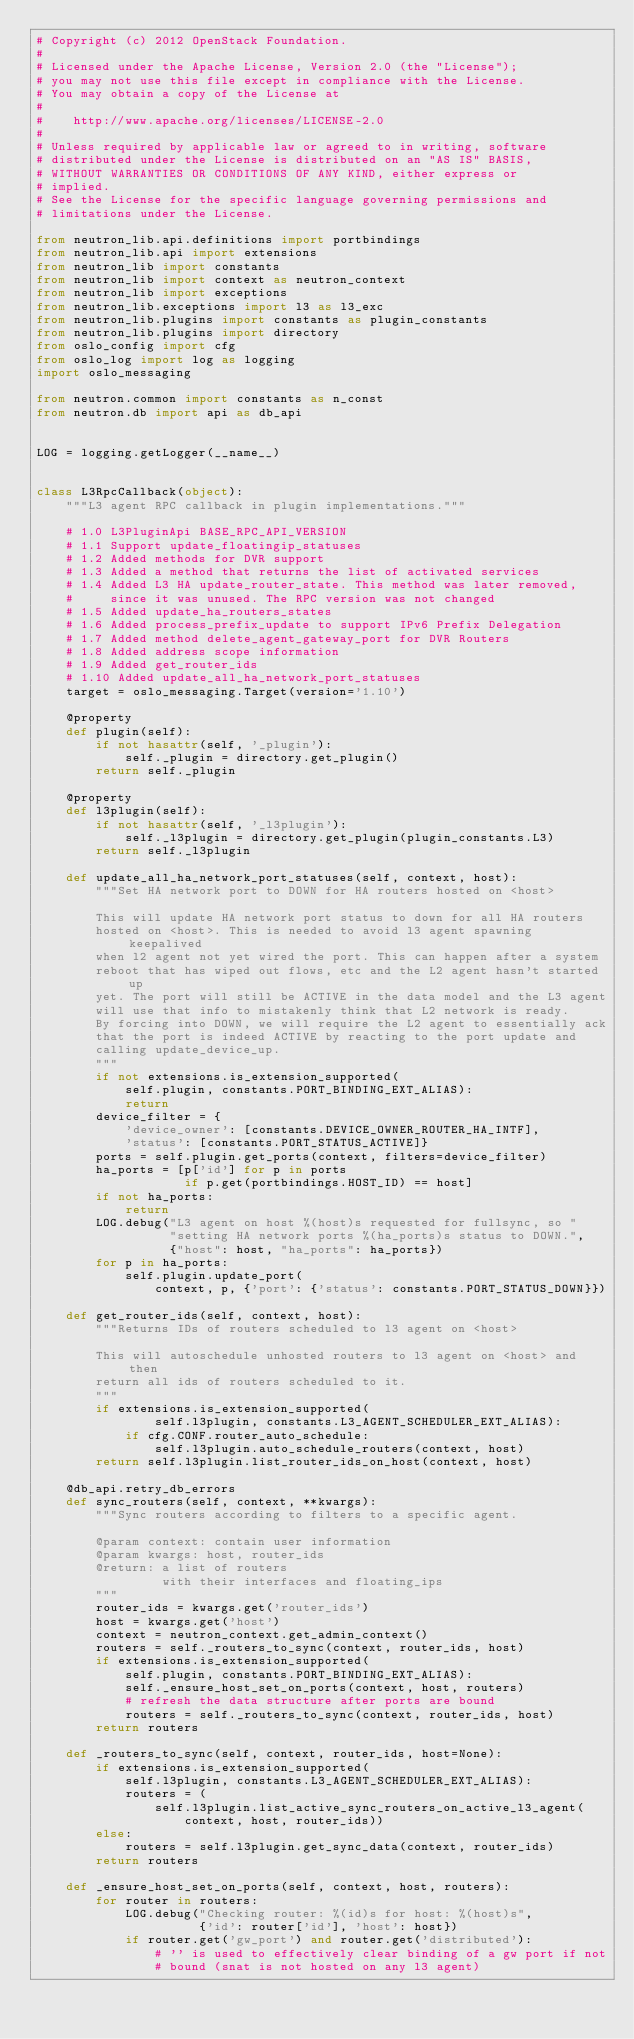<code> <loc_0><loc_0><loc_500><loc_500><_Python_># Copyright (c) 2012 OpenStack Foundation.
#
# Licensed under the Apache License, Version 2.0 (the "License");
# you may not use this file except in compliance with the License.
# You may obtain a copy of the License at
#
#    http://www.apache.org/licenses/LICENSE-2.0
#
# Unless required by applicable law or agreed to in writing, software
# distributed under the License is distributed on an "AS IS" BASIS,
# WITHOUT WARRANTIES OR CONDITIONS OF ANY KIND, either express or
# implied.
# See the License for the specific language governing permissions and
# limitations under the License.

from neutron_lib.api.definitions import portbindings
from neutron_lib.api import extensions
from neutron_lib import constants
from neutron_lib import context as neutron_context
from neutron_lib import exceptions
from neutron_lib.exceptions import l3 as l3_exc
from neutron_lib.plugins import constants as plugin_constants
from neutron_lib.plugins import directory
from oslo_config import cfg
from oslo_log import log as logging
import oslo_messaging

from neutron.common import constants as n_const
from neutron.db import api as db_api


LOG = logging.getLogger(__name__)


class L3RpcCallback(object):
    """L3 agent RPC callback in plugin implementations."""

    # 1.0 L3PluginApi BASE_RPC_API_VERSION
    # 1.1 Support update_floatingip_statuses
    # 1.2 Added methods for DVR support
    # 1.3 Added a method that returns the list of activated services
    # 1.4 Added L3 HA update_router_state. This method was later removed,
    #     since it was unused. The RPC version was not changed
    # 1.5 Added update_ha_routers_states
    # 1.6 Added process_prefix_update to support IPv6 Prefix Delegation
    # 1.7 Added method delete_agent_gateway_port for DVR Routers
    # 1.8 Added address scope information
    # 1.9 Added get_router_ids
    # 1.10 Added update_all_ha_network_port_statuses
    target = oslo_messaging.Target(version='1.10')

    @property
    def plugin(self):
        if not hasattr(self, '_plugin'):
            self._plugin = directory.get_plugin()
        return self._plugin

    @property
    def l3plugin(self):
        if not hasattr(self, '_l3plugin'):
            self._l3plugin = directory.get_plugin(plugin_constants.L3)
        return self._l3plugin

    def update_all_ha_network_port_statuses(self, context, host):
        """Set HA network port to DOWN for HA routers hosted on <host>

        This will update HA network port status to down for all HA routers
        hosted on <host>. This is needed to avoid l3 agent spawning keepalived
        when l2 agent not yet wired the port. This can happen after a system
        reboot that has wiped out flows, etc and the L2 agent hasn't started up
        yet. The port will still be ACTIVE in the data model and the L3 agent
        will use that info to mistakenly think that L2 network is ready.
        By forcing into DOWN, we will require the L2 agent to essentially ack
        that the port is indeed ACTIVE by reacting to the port update and
        calling update_device_up.
        """
        if not extensions.is_extension_supported(
            self.plugin, constants.PORT_BINDING_EXT_ALIAS):
            return
        device_filter = {
            'device_owner': [constants.DEVICE_OWNER_ROUTER_HA_INTF],
            'status': [constants.PORT_STATUS_ACTIVE]}
        ports = self.plugin.get_ports(context, filters=device_filter)
        ha_ports = [p['id'] for p in ports
                    if p.get(portbindings.HOST_ID) == host]
        if not ha_ports:
            return
        LOG.debug("L3 agent on host %(host)s requested for fullsync, so "
                  "setting HA network ports %(ha_ports)s status to DOWN.",
                  {"host": host, "ha_ports": ha_ports})
        for p in ha_ports:
            self.plugin.update_port(
                context, p, {'port': {'status': constants.PORT_STATUS_DOWN}})

    def get_router_ids(self, context, host):
        """Returns IDs of routers scheduled to l3 agent on <host>

        This will autoschedule unhosted routers to l3 agent on <host> and then
        return all ids of routers scheduled to it.
        """
        if extensions.is_extension_supported(
                self.l3plugin, constants.L3_AGENT_SCHEDULER_EXT_ALIAS):
            if cfg.CONF.router_auto_schedule:
                self.l3plugin.auto_schedule_routers(context, host)
        return self.l3plugin.list_router_ids_on_host(context, host)

    @db_api.retry_db_errors
    def sync_routers(self, context, **kwargs):
        """Sync routers according to filters to a specific agent.

        @param context: contain user information
        @param kwargs: host, router_ids
        @return: a list of routers
                 with their interfaces and floating_ips
        """
        router_ids = kwargs.get('router_ids')
        host = kwargs.get('host')
        context = neutron_context.get_admin_context()
        routers = self._routers_to_sync(context, router_ids, host)
        if extensions.is_extension_supported(
            self.plugin, constants.PORT_BINDING_EXT_ALIAS):
            self._ensure_host_set_on_ports(context, host, routers)
            # refresh the data structure after ports are bound
            routers = self._routers_to_sync(context, router_ids, host)
        return routers

    def _routers_to_sync(self, context, router_ids, host=None):
        if extensions.is_extension_supported(
            self.l3plugin, constants.L3_AGENT_SCHEDULER_EXT_ALIAS):
            routers = (
                self.l3plugin.list_active_sync_routers_on_active_l3_agent(
                    context, host, router_ids))
        else:
            routers = self.l3plugin.get_sync_data(context, router_ids)
        return routers

    def _ensure_host_set_on_ports(self, context, host, routers):
        for router in routers:
            LOG.debug("Checking router: %(id)s for host: %(host)s",
                      {'id': router['id'], 'host': host})
            if router.get('gw_port') and router.get('distributed'):
                # '' is used to effectively clear binding of a gw port if not
                # bound (snat is not hosted on any l3 agent)</code> 